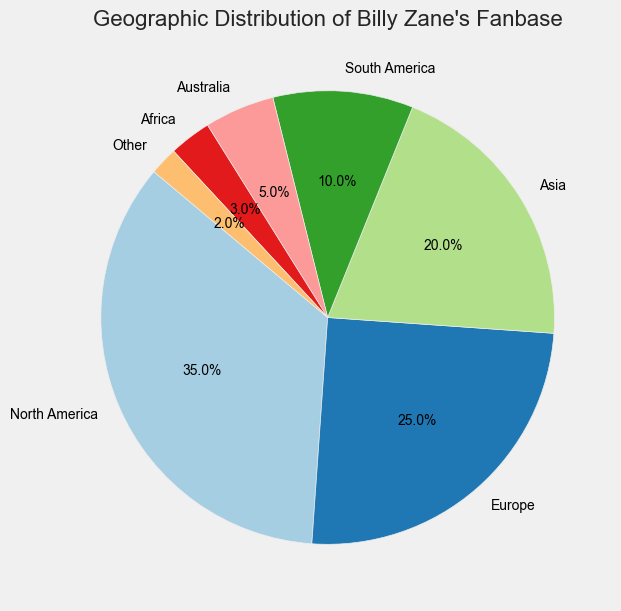Which region has the highest percentage of Billy Zane's fanbase? By looking at the pie chart, the region with the largest wedge represents the highest percentage. In this case, it is North America.
Answer: North America Which region has the lowest percentage of Billy Zane's fanbase? Observing the pie chart, the smallest wedge represents the smallest percentage. In this case, it is Other.
Answer: Other What is the combined percentage of Billy Zane's fanbase in North America and Europe? Add the percentages of North America and Europe from the pie chart. North America is 35% and Europe is 25%, so 35% + 25% = 60%.
Answer: 60% Is the fanbase in Asia larger than that in South America? Compare the percentages shown in the pie chart. Asia has 20% and South America has 10%, so 20% is greater than 10%.
Answer: Yes What is the total percentage of Billy Zane's fanbase outside of North America and Europe? Sum up the percentages of regions other than North America and Europe from the pie chart. These regions (Asia, South America, Australia, Africa, and Other) have 20% + 10% + 5% + 3% + 2% = 40%.
Answer: 40% Which two regions combined have a fanbase percentage close to Asia's fanbase percentage? Check the pie chart for combinations of regions that sum to about 20%. South America (10%) and Australia (5%) together have 15%, which is close but not exact. South America (10%) and Africa (3%) together have 13%, which is farther. South America (10%) and Other (2%) together have 12%, which also is not exact. However, Australia (5%), Africa (3%), and Other (2%) combined have 5% + 3% + 2% = 10%, far from Asia's 20%. Combinations robably not too close. South America's fanbase is far closer to compare solo near 10%.
Answer: South America and Others 